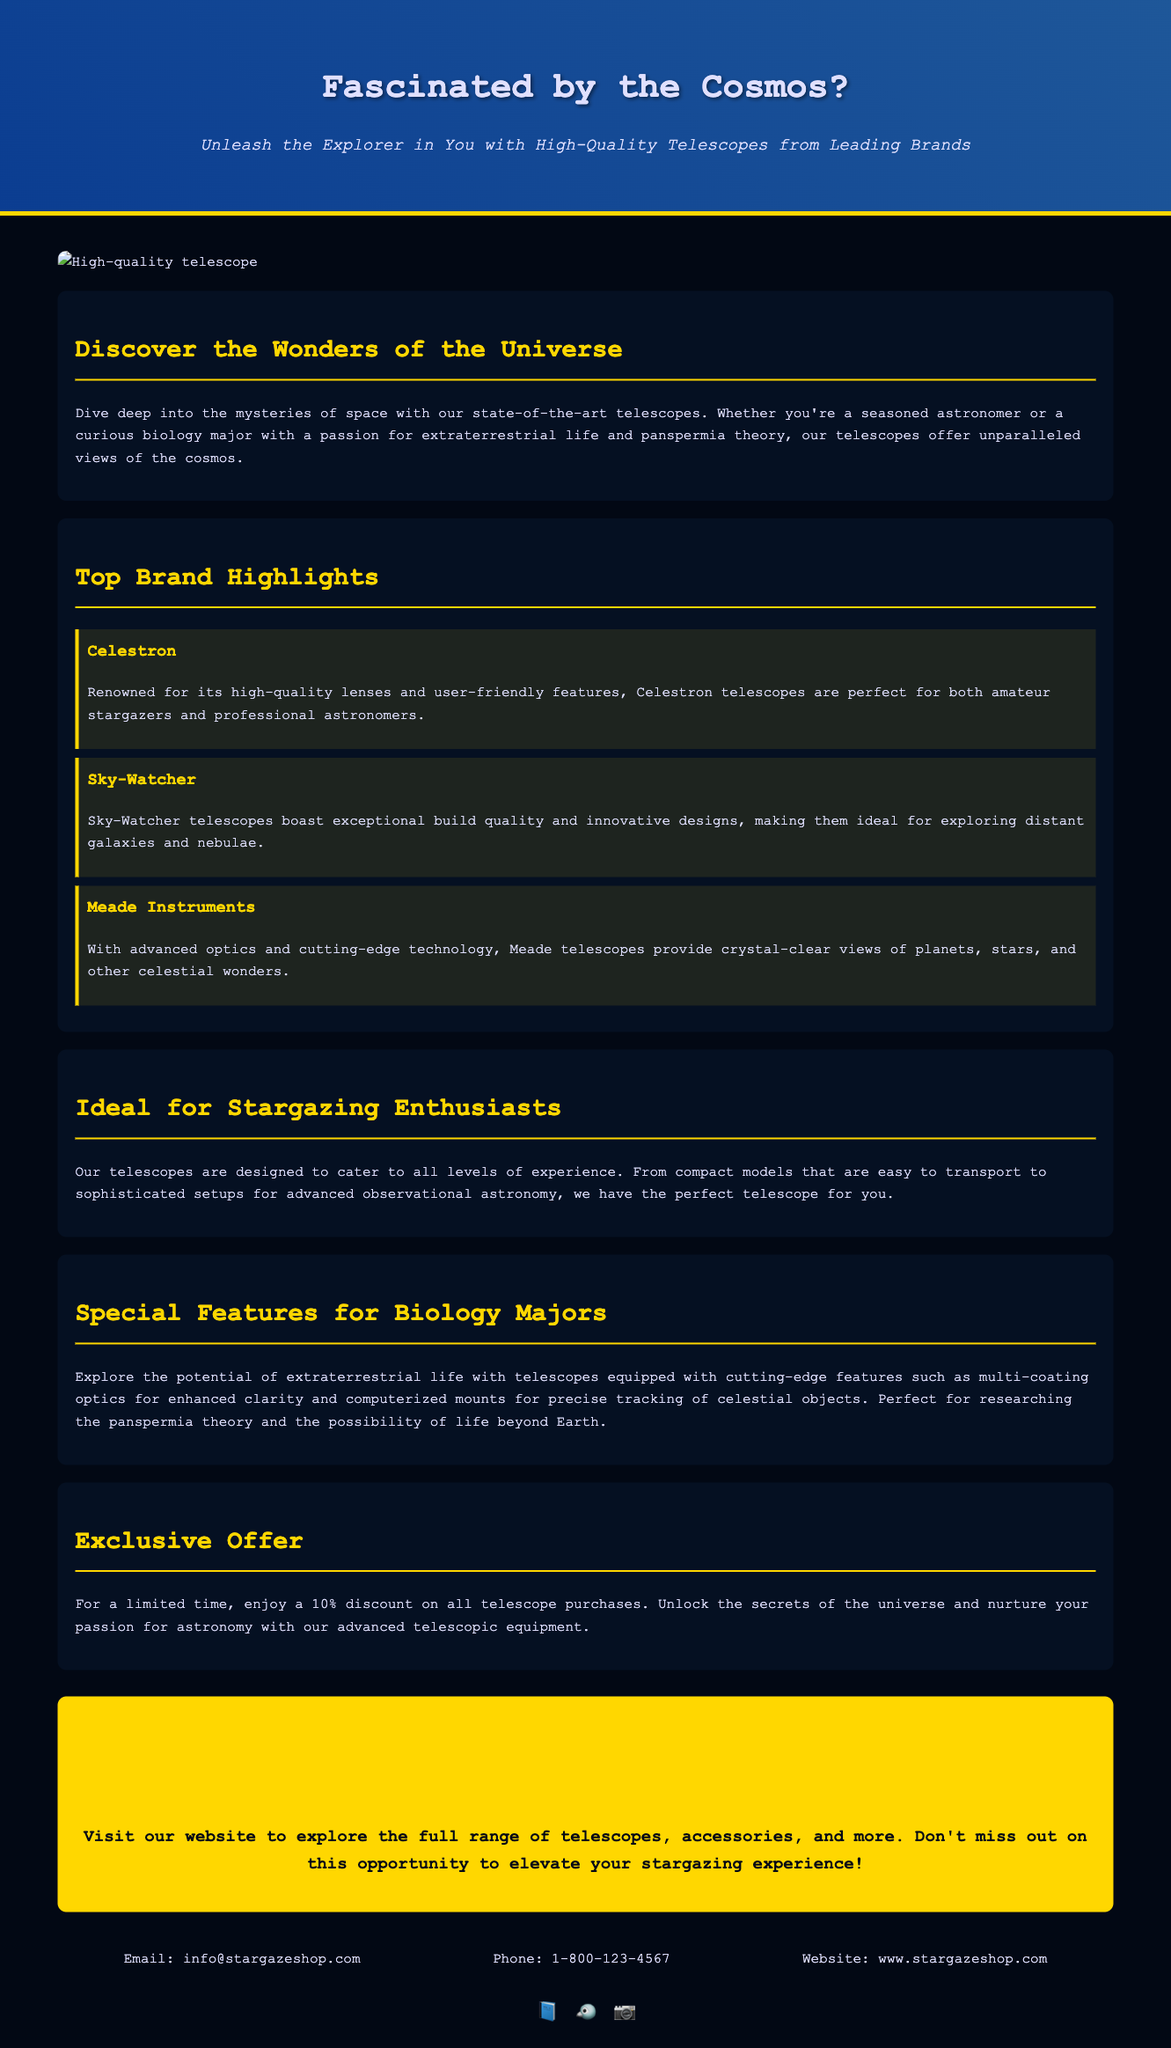What is the title of the advertisement? The title of the advertisement is found in the header section, which presents the main focus of the content.
Answer: Fascinated by the Cosmos? What discount is being offered on telescope purchases? The advertisement mentions a specific promotional offer in the Exclusive Offer section that highlights a limited-time discount.
Answer: 10% Which brands are highlighted in the advertisement? The advertisement lists three brands in the Top Brand Highlights section.
Answer: Celestron, Sky-Watcher, Meade Instruments What kind of optics do the telescopes feature? The Special Features for Biology Majors section describes a specific characteristic of the telescopes that enhances their performance.
Answer: Multi-coating optics What is the primary target audience of the advertisement? The advertisement presents various audiences, but one specific mention is made in the introduction.
Answer: Stargazing Enthusiasts 